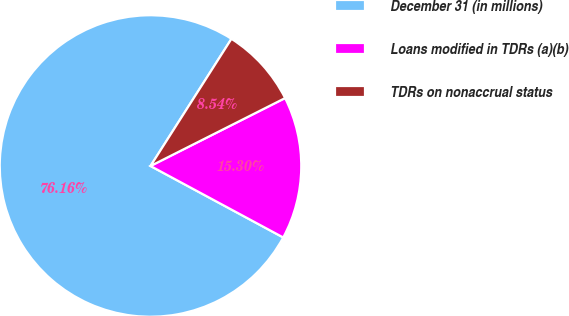<chart> <loc_0><loc_0><loc_500><loc_500><pie_chart><fcel>December 31 (in millions)<fcel>Loans modified in TDRs (a)(b)<fcel>TDRs on nonaccrual status<nl><fcel>76.16%<fcel>15.3%<fcel>8.54%<nl></chart> 